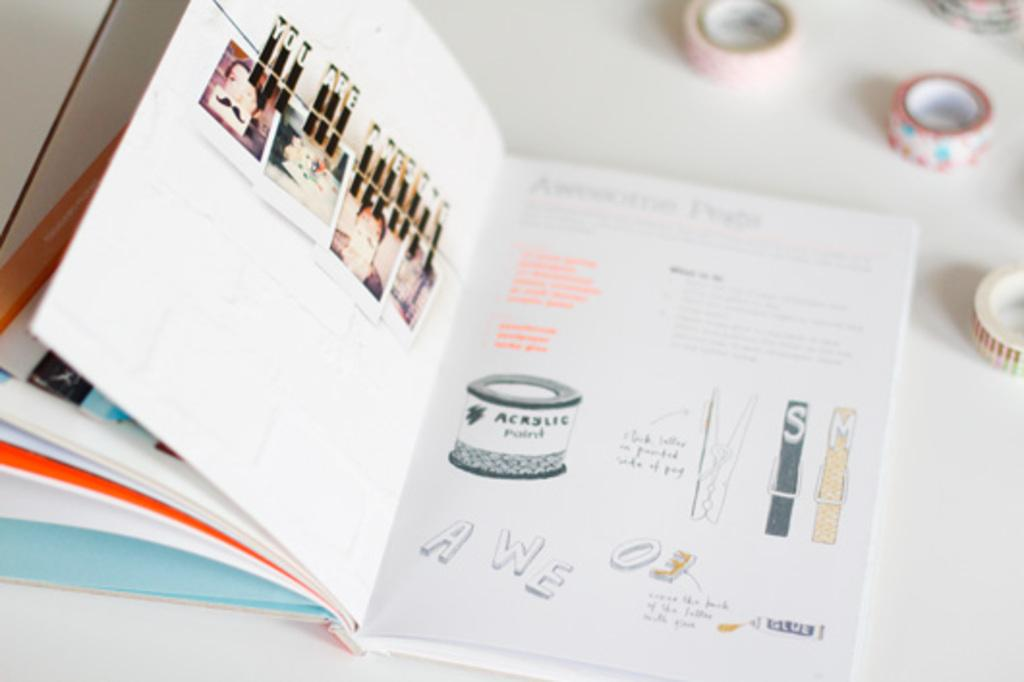<image>
Create a compact narrative representing the image presented. A book on art shows a container of acrylic paint. 